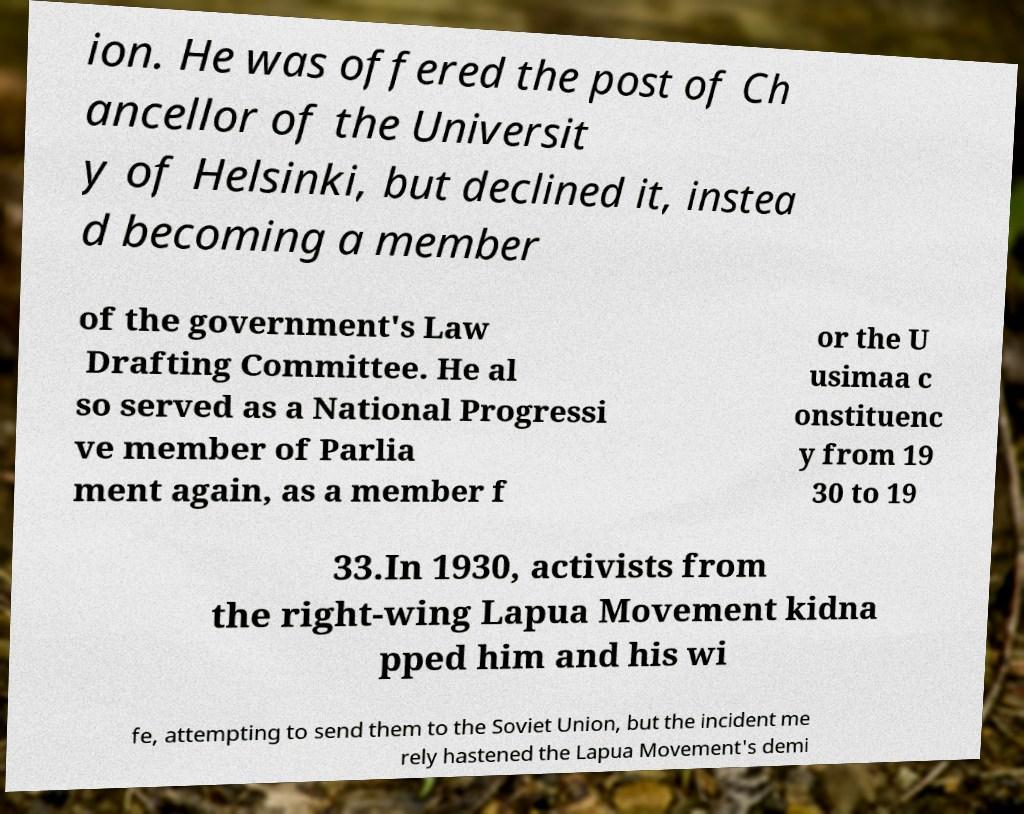For documentation purposes, I need the text within this image transcribed. Could you provide that? ion. He was offered the post of Ch ancellor of the Universit y of Helsinki, but declined it, instea d becoming a member of the government's Law Drafting Committee. He al so served as a National Progressi ve member of Parlia ment again, as a member f or the U usimaa c onstituenc y from 19 30 to 19 33.In 1930, activists from the right-wing Lapua Movement kidna pped him and his wi fe, attempting to send them to the Soviet Union, but the incident me rely hastened the Lapua Movement's demi 